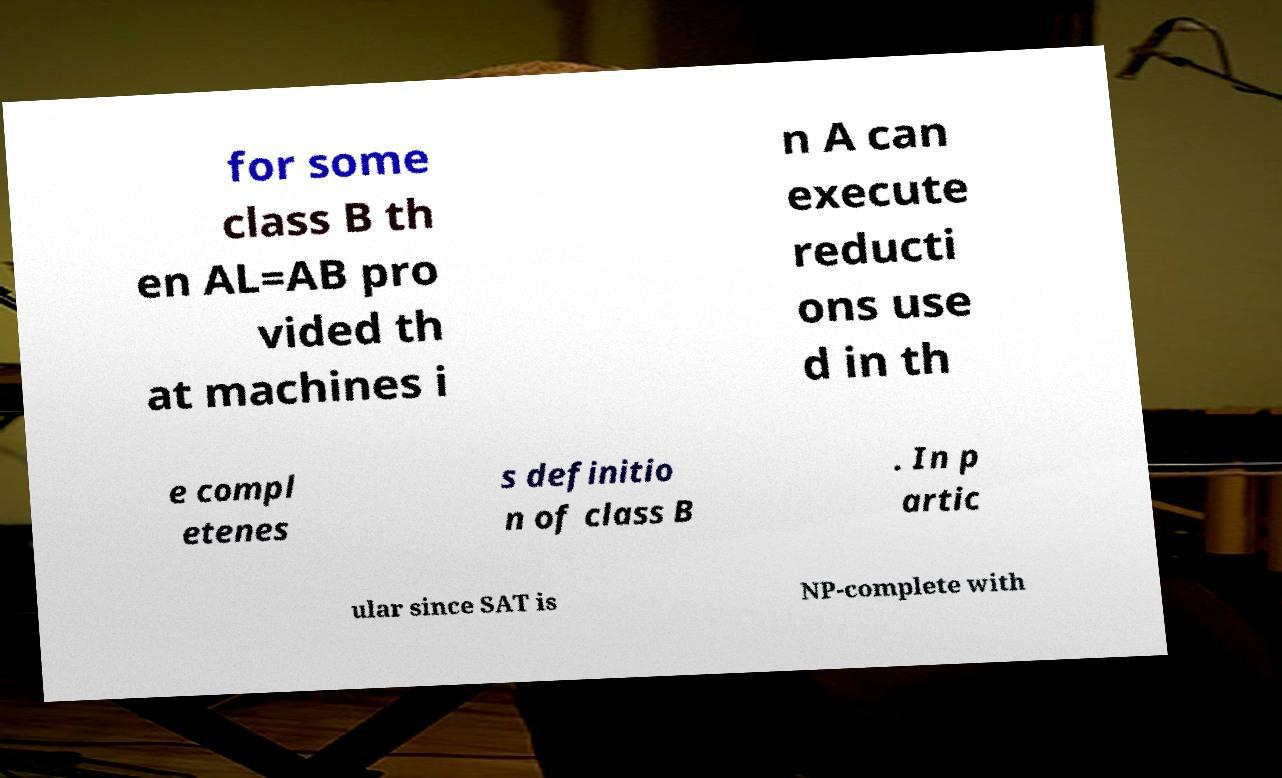I need the written content from this picture converted into text. Can you do that? for some class B th en AL=AB pro vided th at machines i n A can execute reducti ons use d in th e compl etenes s definitio n of class B . In p artic ular since SAT is NP-complete with 